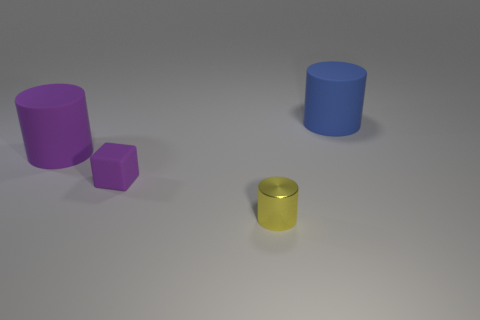Is there anything else that is the same shape as the tiny matte thing?
Ensure brevity in your answer.  No. What is the size of the rubber cube?
Your answer should be very brief. Small. Does the matte cube have the same size as the yellow shiny cylinder?
Offer a terse response. Yes. There is a large cylinder on the right side of the small matte object; what material is it?
Provide a short and direct response. Rubber. There is a tiny yellow object that is the same shape as the big blue thing; what is it made of?
Make the answer very short. Metal. There is a large cylinder in front of the large blue rubber object; are there any yellow things to the right of it?
Make the answer very short. Yes. Do the yellow shiny object and the blue object have the same shape?
Offer a terse response. Yes. What is the shape of the large blue thing that is made of the same material as the large purple cylinder?
Your answer should be compact. Cylinder. Do the rubber cylinder that is on the left side of the blue object and the cylinder behind the purple rubber cylinder have the same size?
Provide a succinct answer. Yes. Are there more big things that are left of the small metallic object than big blue rubber objects that are in front of the large blue cylinder?
Offer a very short reply. Yes. 